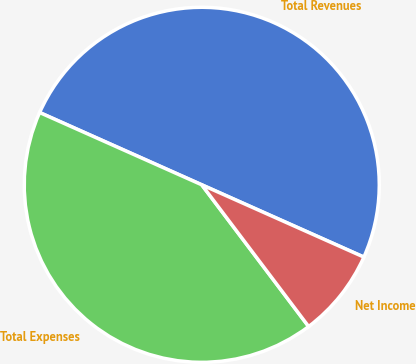Convert chart to OTSL. <chart><loc_0><loc_0><loc_500><loc_500><pie_chart><fcel>Total Revenues<fcel>Total Expenses<fcel>Net Income<nl><fcel>50.0%<fcel>41.96%<fcel>8.04%<nl></chart> 